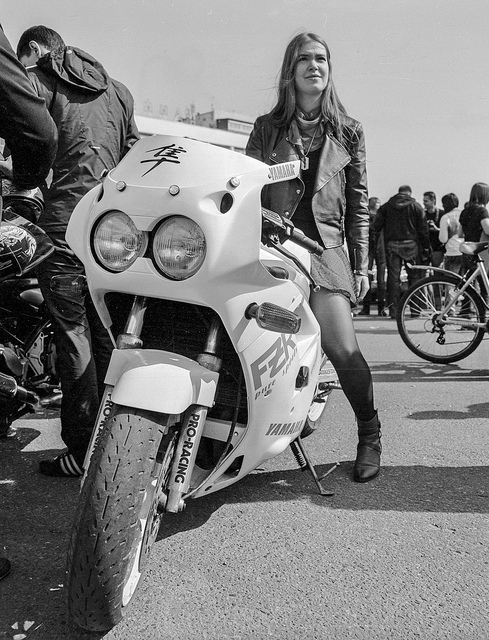<image>Where is an American flag in the picture? There is no American flag in the picture. Where is an American flag in the picture? There is no American flag in the picture. 